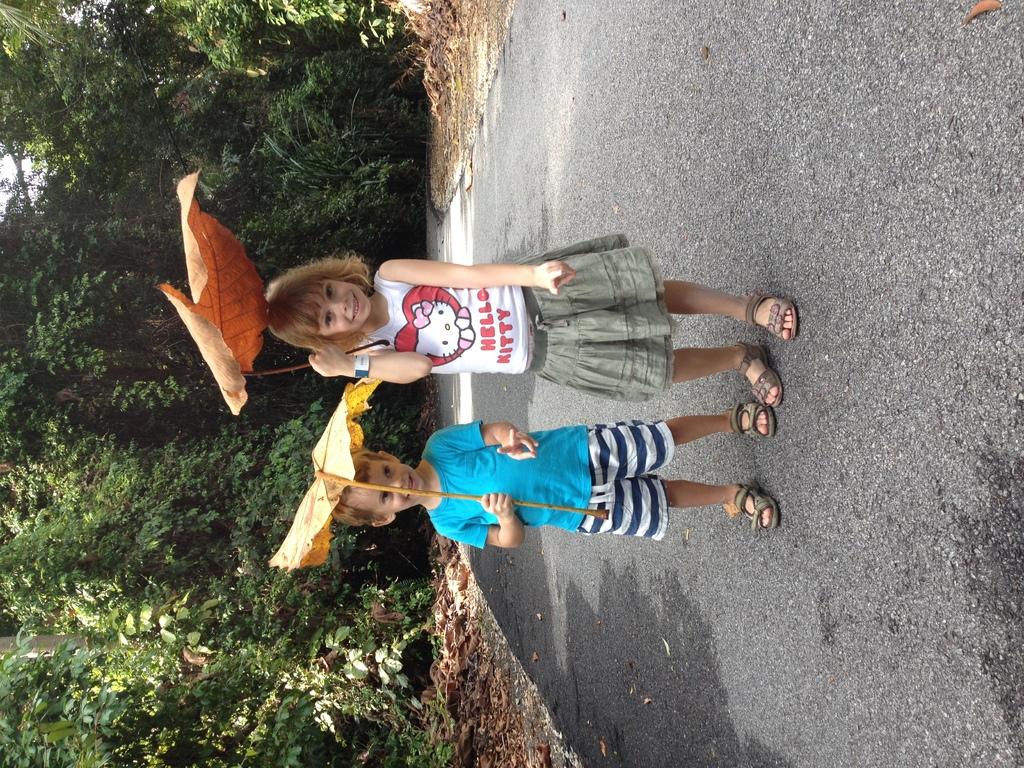Does the girl have hello kitty on her shirt?
Provide a succinct answer. Yes. 